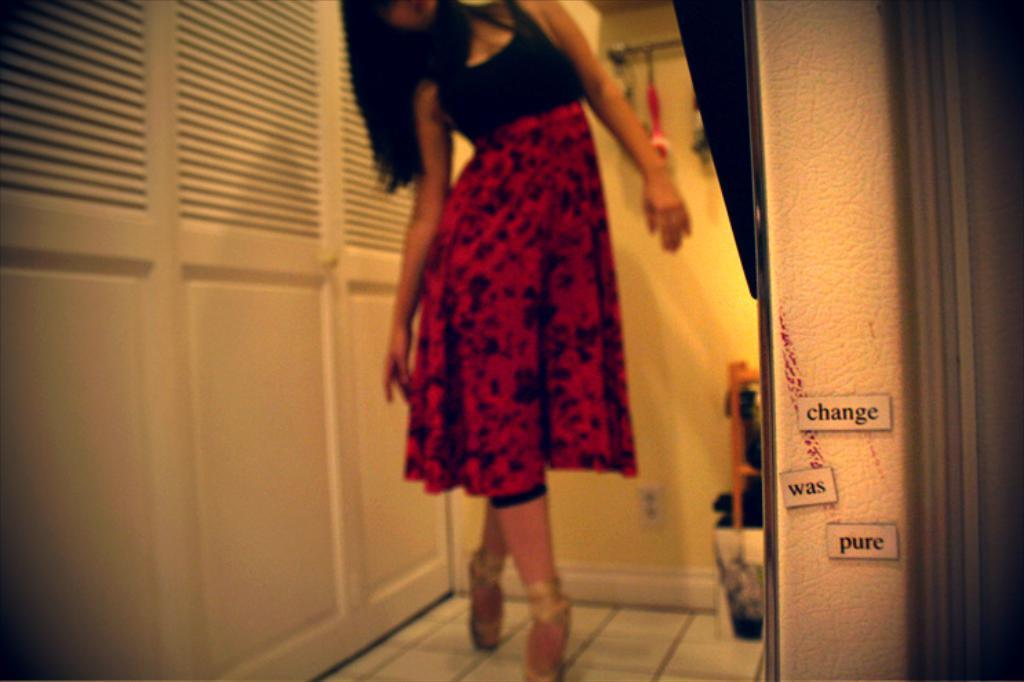What is the main subject in the foreground of the picture? There is a woman standing in the foreground of the picture. What is the woman standing on? The woman is standing on tiles. What can be seen on the right side of the image? There is a text paper pasted on a wall on the right side of the image. What type of furniture is visible in the background of the image? There are cupboards in the background of the image. What else can be seen in the background of the image? There is a wall visible in the background of the image. What type of hat is the woman wearing in the image? There is no hat visible in the image; the woman is not wearing a hat. 